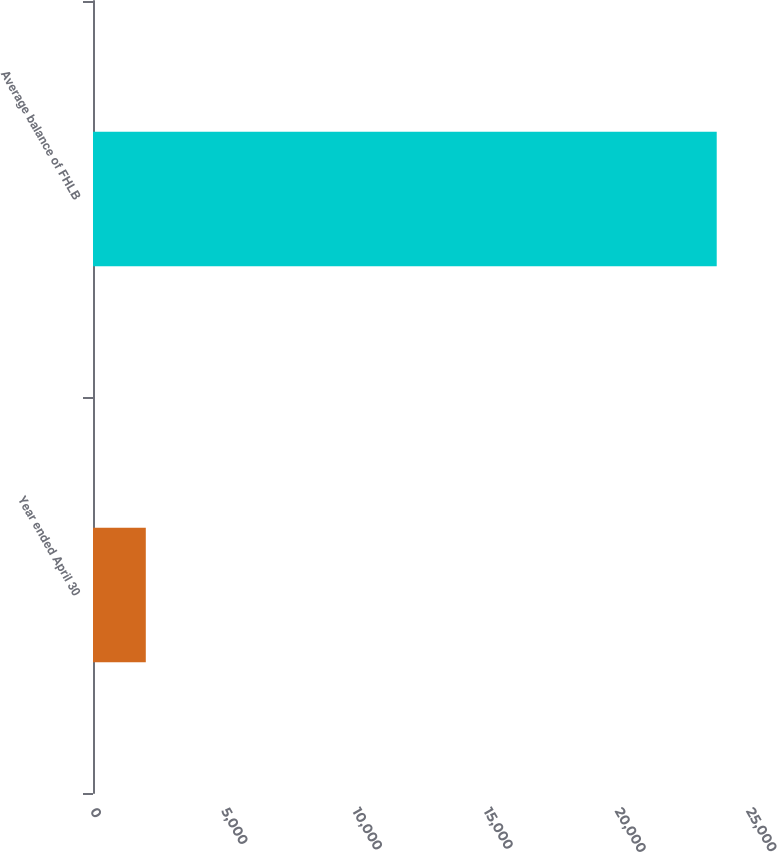Convert chart. <chart><loc_0><loc_0><loc_500><loc_500><bar_chart><fcel>Year ended April 30<fcel>Average balance of FHLB<nl><fcel>2012<fcel>23770<nl></chart> 